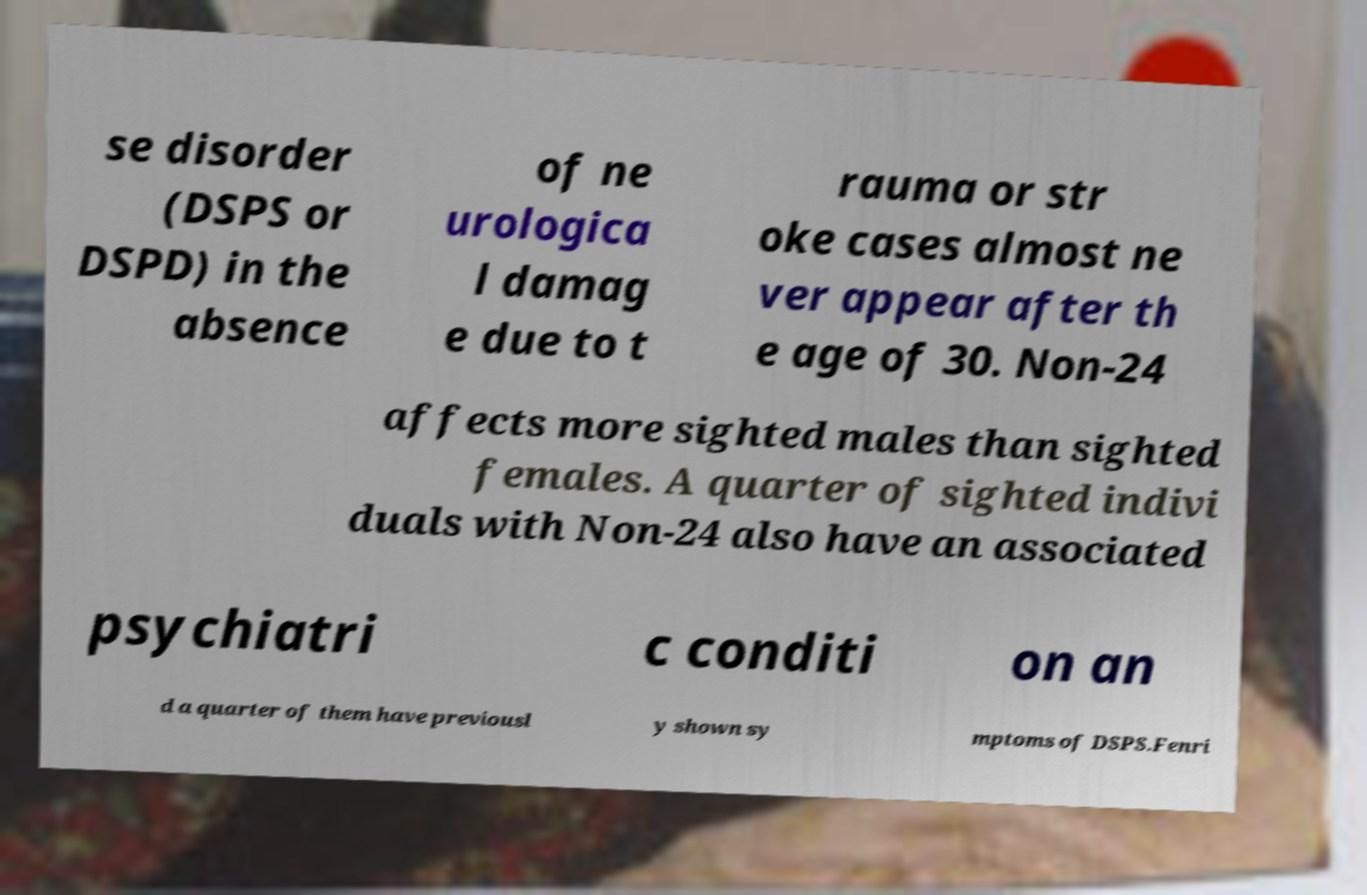There's text embedded in this image that I need extracted. Can you transcribe it verbatim? se disorder (DSPS or DSPD) in the absence of ne urologica l damag e due to t rauma or str oke cases almost ne ver appear after th e age of 30. Non-24 affects more sighted males than sighted females. A quarter of sighted indivi duals with Non-24 also have an associated psychiatri c conditi on an d a quarter of them have previousl y shown sy mptoms of DSPS.Fenri 